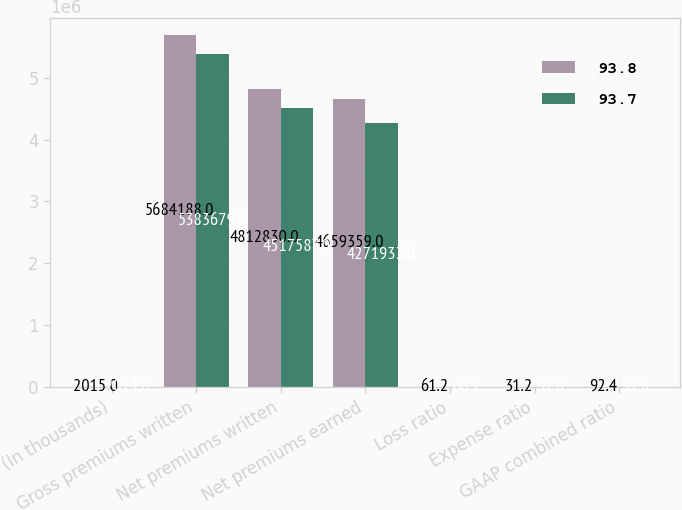Convert chart. <chart><loc_0><loc_0><loc_500><loc_500><stacked_bar_chart><ecel><fcel>(In thousands)<fcel>Gross premiums written<fcel>Net premiums written<fcel>Net premiums earned<fcel>Loss ratio<fcel>Expense ratio<fcel>GAAP combined ratio<nl><fcel>93.8<fcel>2015<fcel>5.68419e+06<fcel>4.81283e+06<fcel>4.65936e+06<fcel>61.2<fcel>31.2<fcel>92.4<nl><fcel>93.7<fcel>2014<fcel>5.38368e+06<fcel>4.51759e+06<fcel>4.27193e+06<fcel>60.2<fcel>31.6<fcel>91.8<nl></chart> 